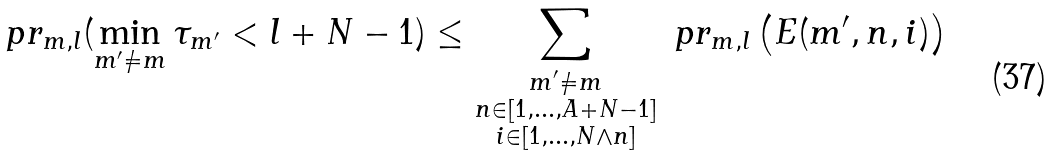<formula> <loc_0><loc_0><loc_500><loc_500>\ p r _ { m , l } ( \min _ { m ^ { \prime } \ne m } \tau _ { m ^ { \prime } } < l + N - 1 ) \leq \sum _ { \substack { m ^ { \prime } \ne m \\ n \in [ 1 , \dots , A + N - 1 ] \\ i \in [ 1 , \dots , N \wedge n ] } } \ p r _ { m , l } \left ( E ( m ^ { \prime } , n , i ) \right )</formula> 